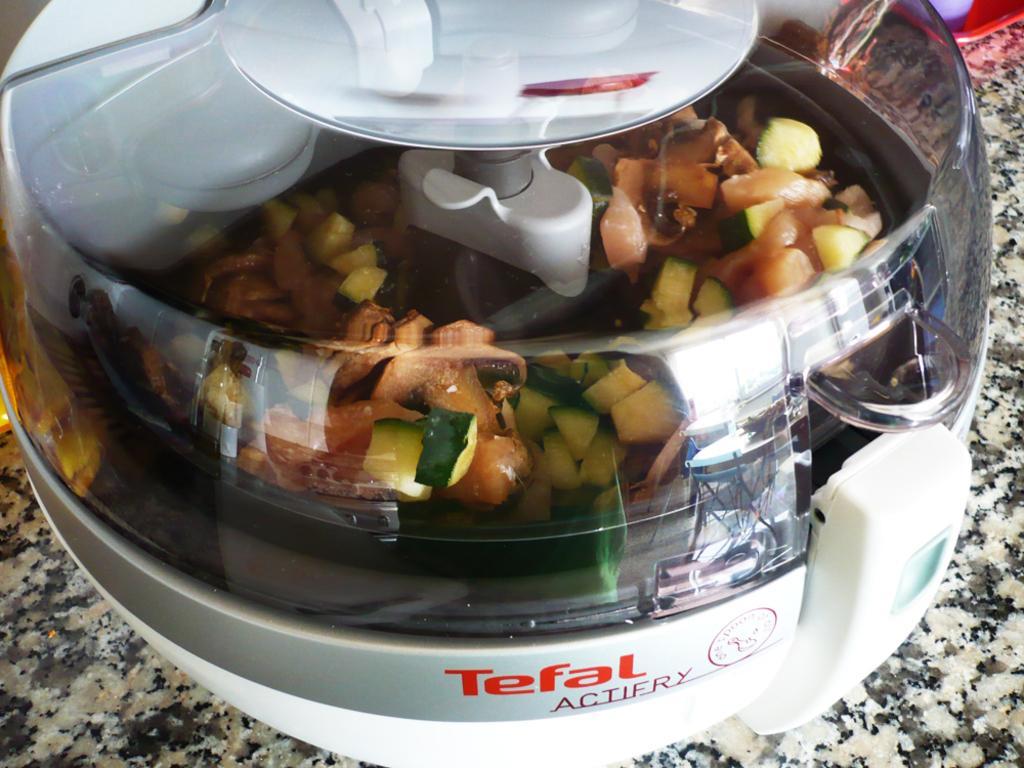Could you give a brief overview of what you see in this image? In this image there is a blender with some stuff. 